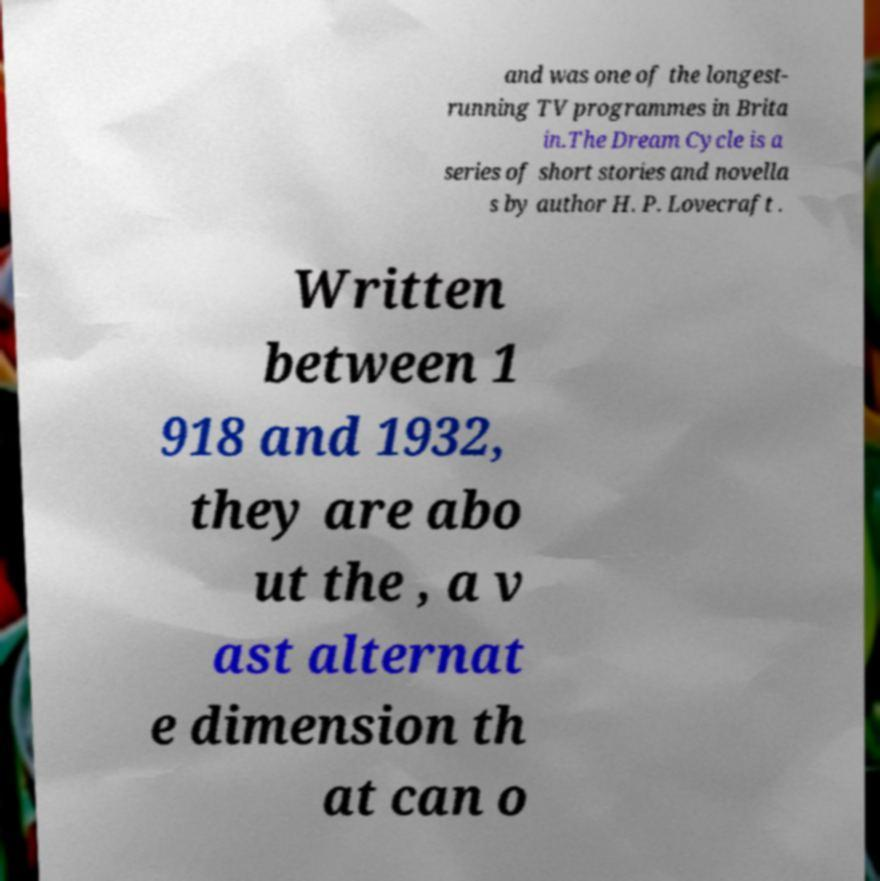There's text embedded in this image that I need extracted. Can you transcribe it verbatim? and was one of the longest- running TV programmes in Brita in.The Dream Cycle is a series of short stories and novella s by author H. P. Lovecraft . Written between 1 918 and 1932, they are abo ut the , a v ast alternat e dimension th at can o 